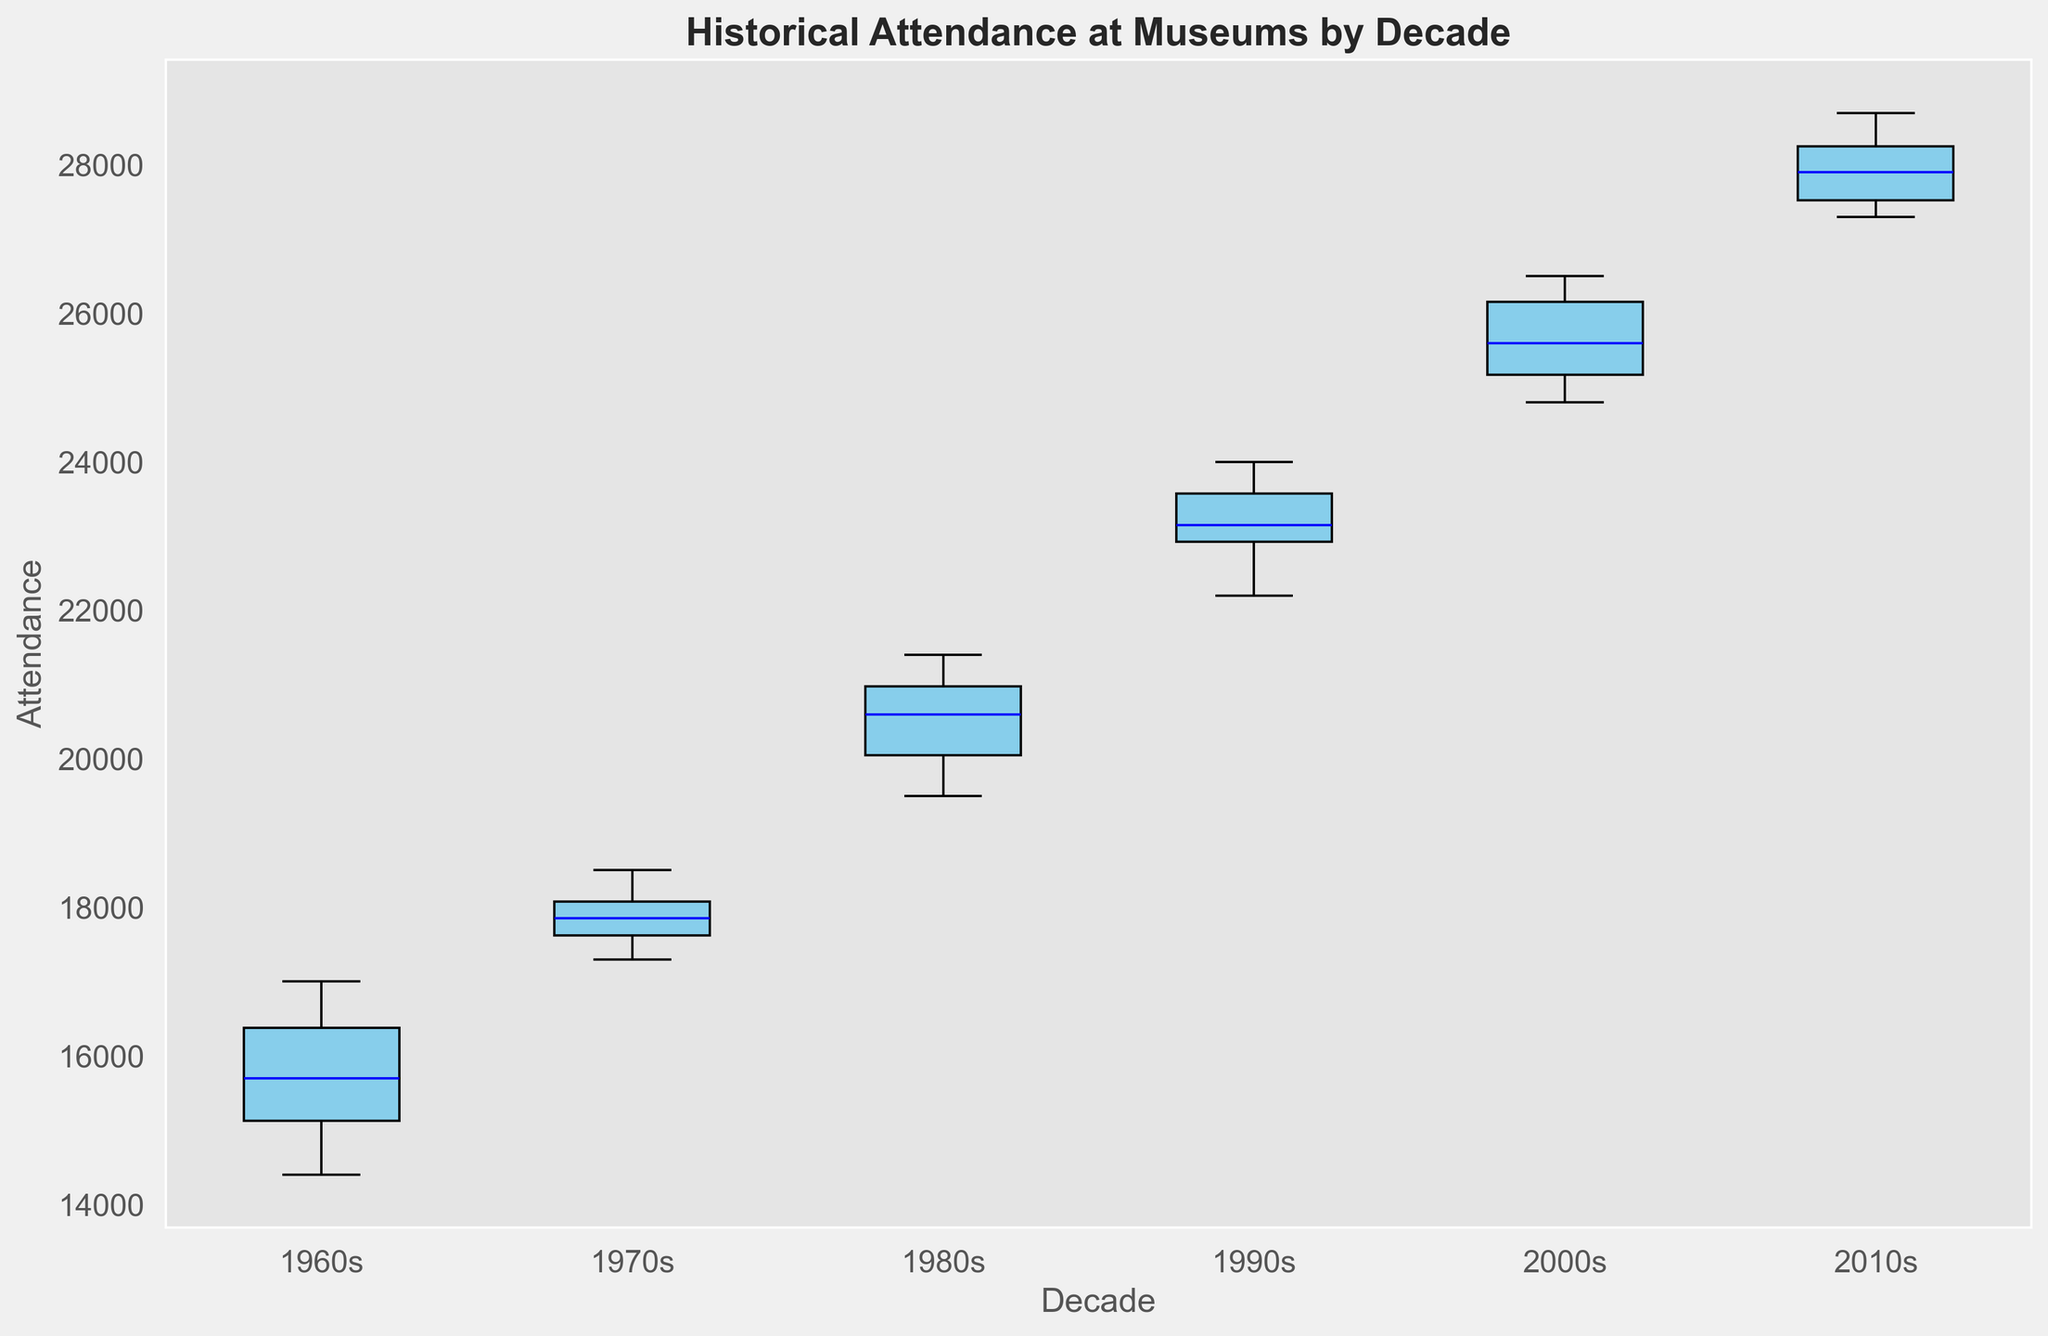What is the median attendance for the 1980s? To find the median attendance for the 1980s, look at the box plot for the 1980s and identify the line inside the box, which represents the median value.
Answer: 20500 Which decade had the lowest overall attendance range? The overall attendance range can be determined by looking at the length of the whiskers for each decade. The shortest whiskers indicate the smallest range.
Answer: 1960s How does the median attendance in the 2000s compare to that of the 1960s? Locate the median lines inside the boxes for both the 2000s and the 1960s. Compare their positions on the y-axis. The 2000s median is higher.
Answer: Higher Which decade has the highest median attendance? The highest median attendance is indicated by the tallest median line, which can be found by examining the respective medians for each decade.
Answer: 2010s What is the approximate interquartile range (IQR) for the 1990s? The IQR is the difference between the upper and lower quartiles (the top and bottom of the box). Measure this distance in the box plot for the 1990s.
Answer: 4000 Which decade shows the most variation in attendance? The most variation is shown by the decade with the longest whiskers and the largest spread of the box.
Answer: 2000s Compare the median attendance of the 1970s to the lowest attendance value of the 2010s. Which is higher? Identify the median in the 1970s box plot and the lowest whisker value in the 2010s box plot, and compare these values.
Answer: 2010s What decade had the highest minimum attendance? Look at the lowest points of the whiskers for each decade and identify which is the highest.
Answer: 2010s Which two decades have the smallest difference between their medians? Compare the median lines inside the boxes for each pair of decades and find the two that are closest.
Answer: 1980s and 1990s Identify the decade with the second-highest median attendance and provide the value. Rank the median lines for each decade from highest to lowest and pick the second-highest.
Answer: 2000s, 25500 